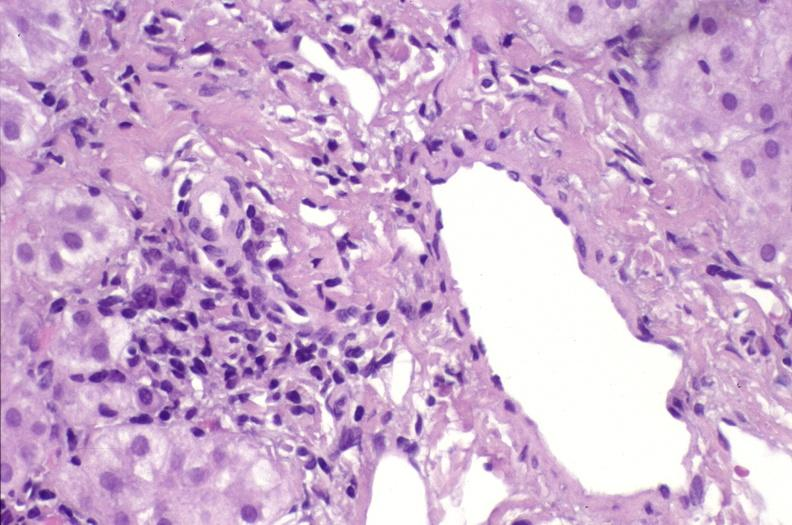s liver present?
Answer the question using a single word or phrase. Yes 